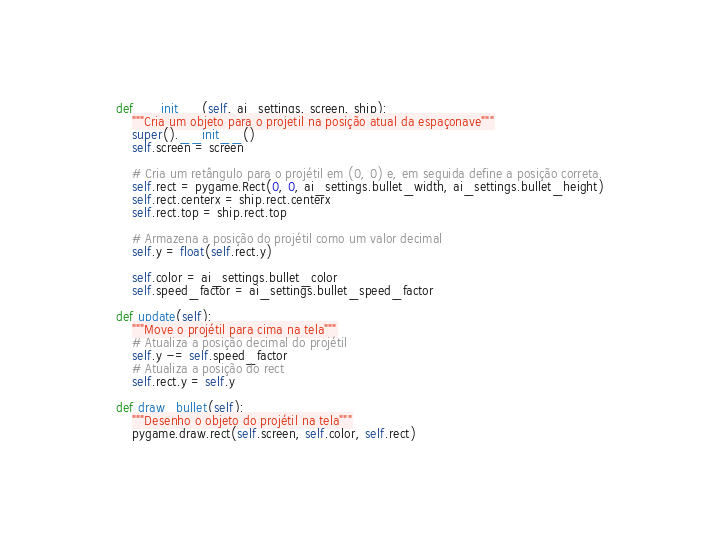Convert code to text. <code><loc_0><loc_0><loc_500><loc_500><_Python_>    def __init__(self, ai_settings, screen, ship):
        """Cria um objeto para o projetil na posição atual da espaçonave"""
        super().__init__()
        self.screen = screen

        # Cria um retângulo para o projétil em (0, 0) e, em seguida define a posição correta.
        self.rect = pygame.Rect(0, 0, ai_settings.bullet_width, ai_settings.bullet_height)
        self.rect.centerx = ship.rect.centerx
        self.rect.top = ship.rect.top

        # Armazena a posição do projétil como um valor decimal
        self.y = float(self.rect.y)

        self.color = ai_settings.bullet_color
        self.speed_factor = ai_settings.bullet_speed_factor

    def update(self):
        """Move o projétil para cima na tela"""
        # Atualiza a posição decimal do projétil
        self.y -= self.speed_factor
        # Atualiza a posição do rect
        self.rect.y = self.y

    def draw_bullet(self):
        """Desenho o objeto do projétil na tela"""
        pygame.draw.rect(self.screen, self.color, self.rect)







</code> 